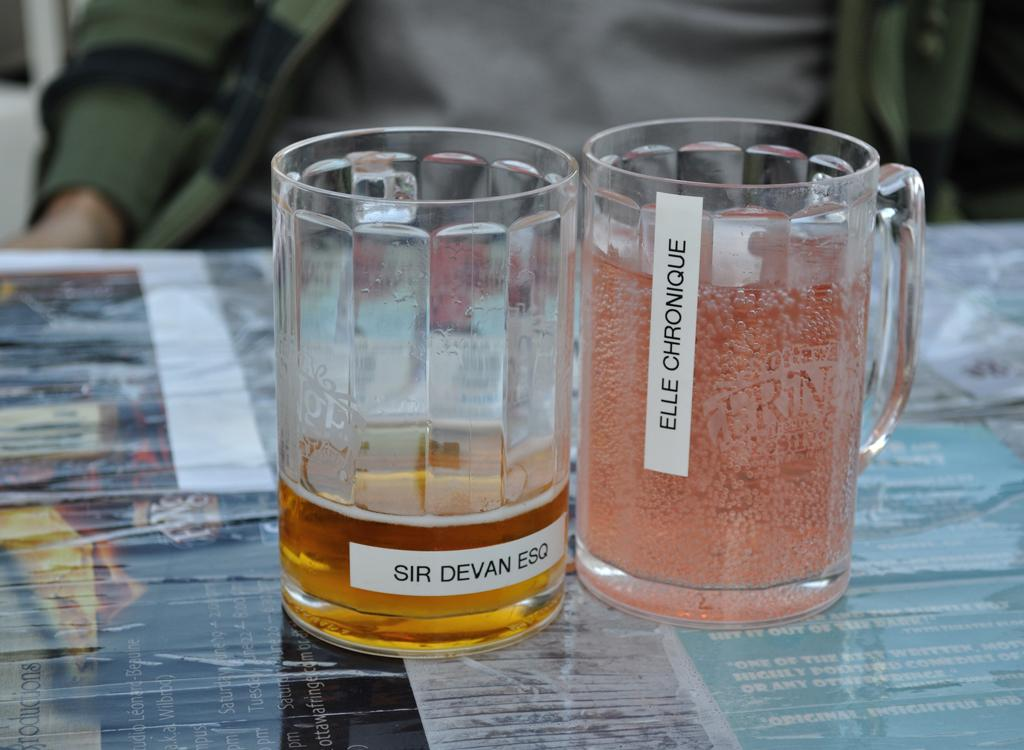<image>
Offer a succinct explanation of the picture presented. A full beverage glass with Elle Chronique on it next to an almost empty beverage glass with Sir Devan Esq on it 